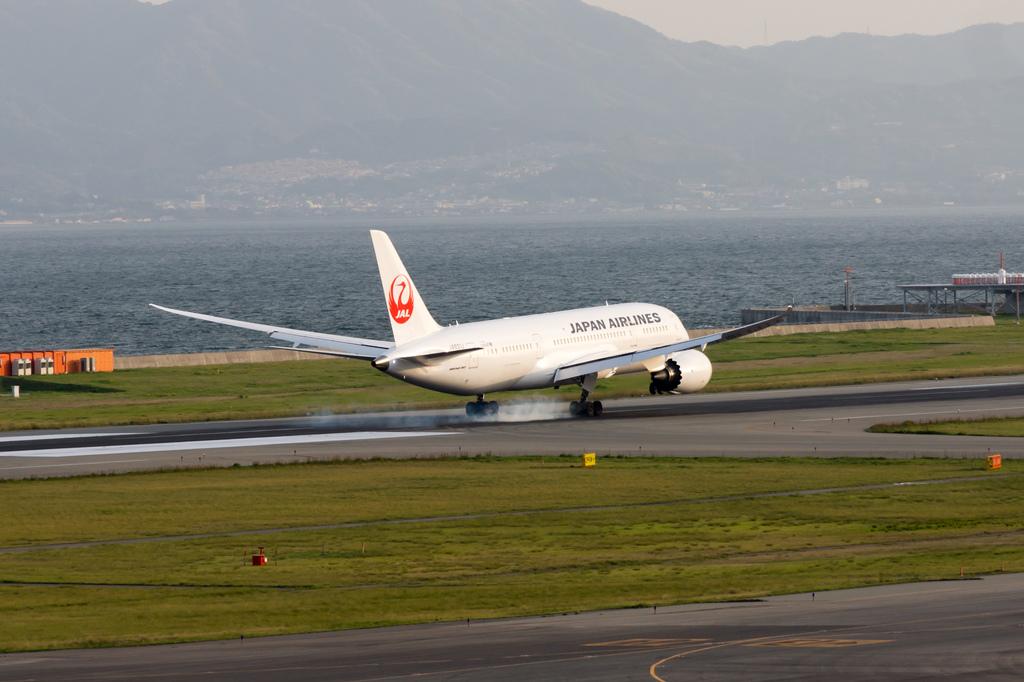What country is this airline headquartered in?
Offer a very short reply. Japan. What color is the country written on the airplane?
Ensure brevity in your answer.  Black. 